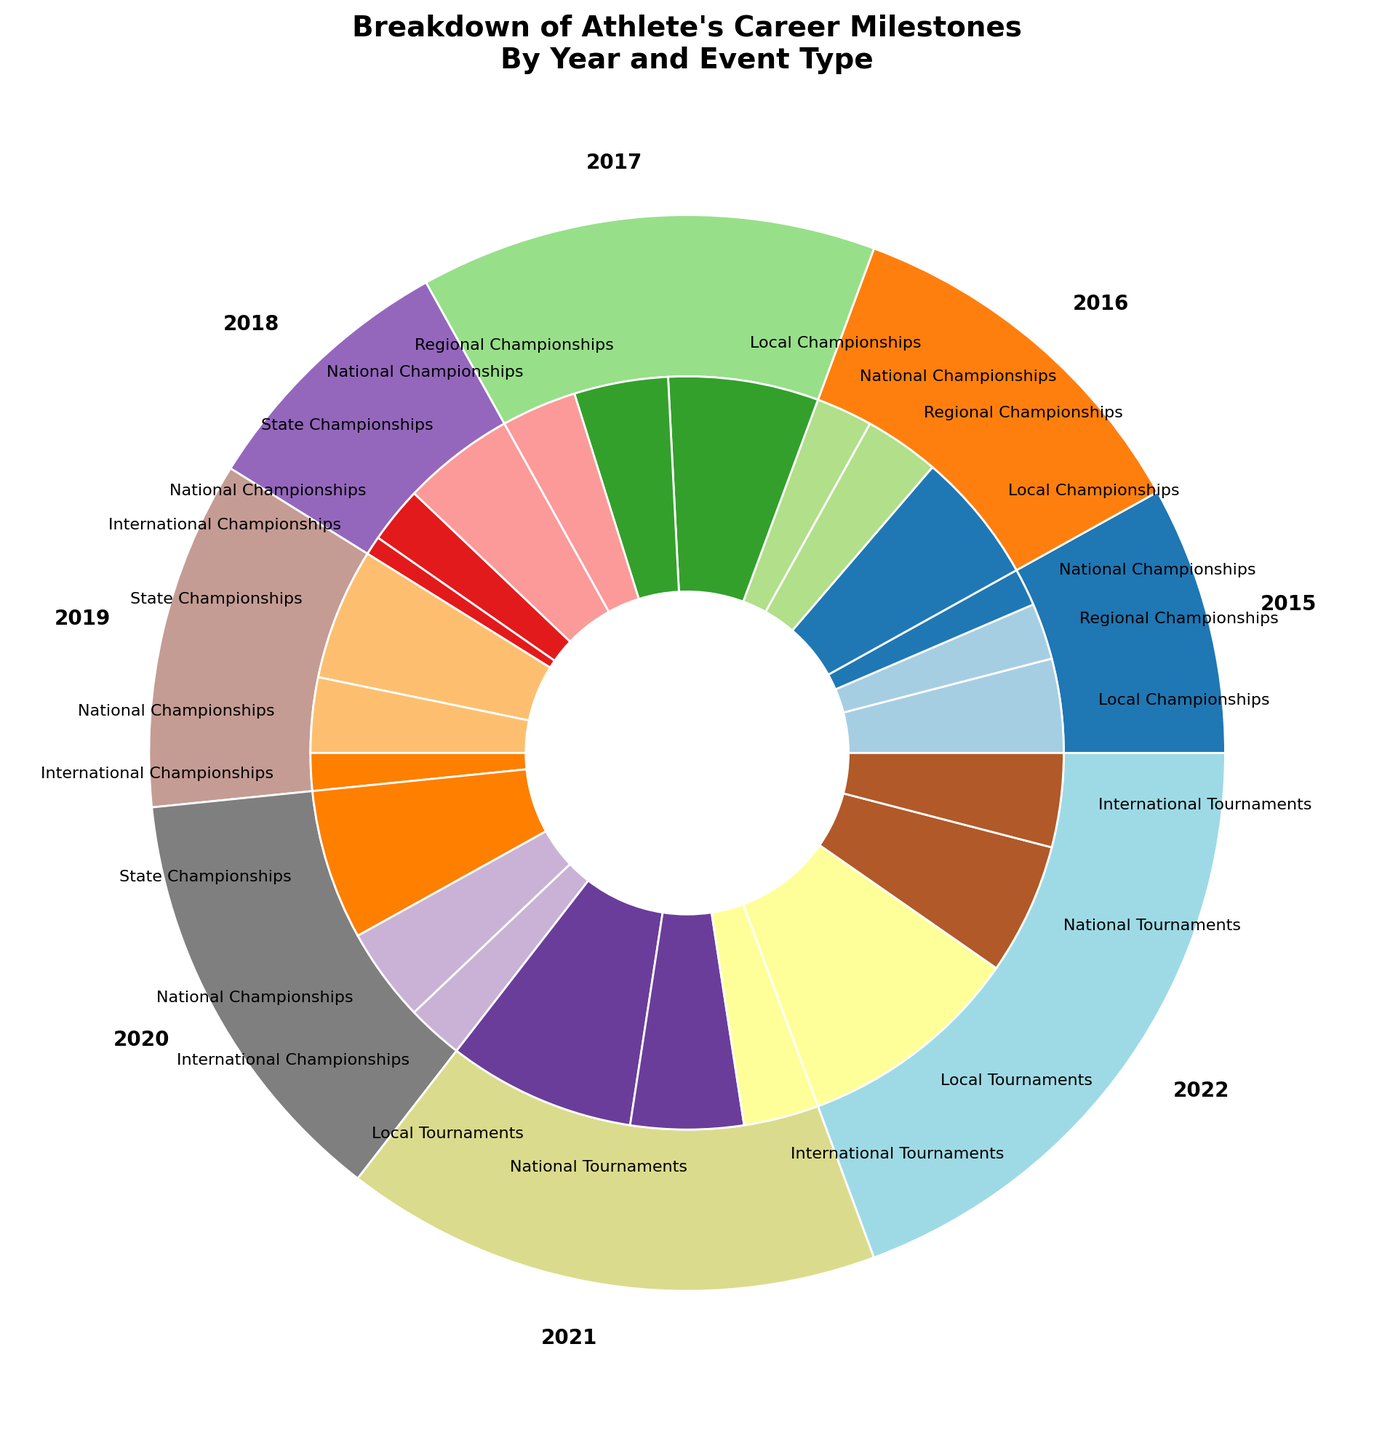What year had the highest number of career milestones? To determine the year with the highest number of career milestones, we need to look at the outer pie chart's slices and compare their sizes. The year with the largest slice represents the highest number of career milestones. Viewing the outer pie chart, 2022 has the largest slice.
Answer: 2022 How many total events were there in 2017? To find the total events in 2017, sum up the counts of all subcategories in the inner pie chart for that year: Local Championships (8), Regional Championships (5), and National Championships (4). Adding these gives 8 + 5 + 4 = 17.
Answer: 17 Which category had the fewest events in 2020? In the inner pie chart for 2020, examine the segments to find which subcategory had the smallest size. The options are State Championships (8), National Championships (5), and International Championships (3). The smallest number is 3 for International Championships.
Answer: International Championships Did the athlete participate in more National Tournaments or Local Tournaments in 2022? Compare the counts of National Tournaments and Local Tournaments for 2022 in the inner pie chart. Local Tournaments had 12 events, while National Tournaments had 7. Hence, the athlete participated in more Local Tournaments.
Answer: Local Tournaments What is the total number of International competitions the athlete participated in from 2018 to 2022? Calculate the total by summing the number of International Championships/Tournaments from each year: 2018 (1), 2019 (2), 2020 (3), 2021 (4), and 2022 (5). Therefore, 1 + 2 + 3 + 4 + 5 = 15.
Answer: 15 Which year saw the transition from Youth Competitions to Professional Competitions? Compare the outer pie chart segments to see the first occurrence of Professional Competitions after the last Youth Competitions. The transition happened from 2020 to 2021.
Answer: 2021 How many more events did the athlete participate in 2016 compared to 2015? Calculate the total events for 2016 and 2015 by summing their inner pie chart segments: 2016 had Local Championships (7), Regional Championships (4), and National Championships (3) amounting to 7 + 4 + 3 = 14, and 2015 had Local Championships (5), Regional Championships (3), and National Championships (2) amounting to 5 + 3 + 2 = 10. Thus, 14 - 10 = 4 more events in 2016.
Answer: 4 In which category did the athlete have an increasing trend of event participation from 2019 to 2022? Look at each event type from 2019 to 2022 within the inner pie chart. Identify a clear upward trend. State Championships had counts of 7 (2019), 8 (2020), and jumped to Professional Competitions in 2021. Local Tournaments show a clear increase: 10 (2021), 12 (2022). Hence, the category showing a clear increasing trend is Local Tournaments in Professional Competitions.
Answer: Local Tournaments 